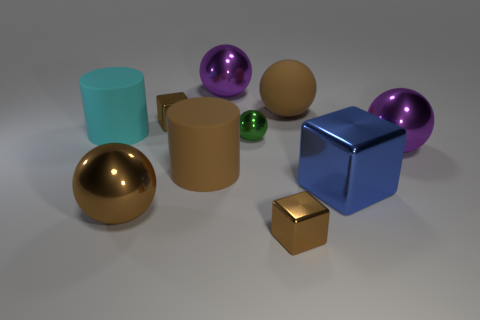Subtract all blue cubes. How many cubes are left? 2 Subtract all cylinders. How many objects are left? 8 Subtract 1 cylinders. How many cylinders are left? 1 Subtract all blue spheres. Subtract all yellow blocks. How many spheres are left? 5 Subtract all brown cubes. How many gray balls are left? 0 Subtract all brown metallic spheres. Subtract all brown balls. How many objects are left? 7 Add 5 large metal balls. How many large metal balls are left? 8 Add 8 tiny purple rubber spheres. How many tiny purple rubber spheres exist? 8 Subtract all blue cubes. How many cubes are left? 2 Subtract 2 brown balls. How many objects are left? 8 